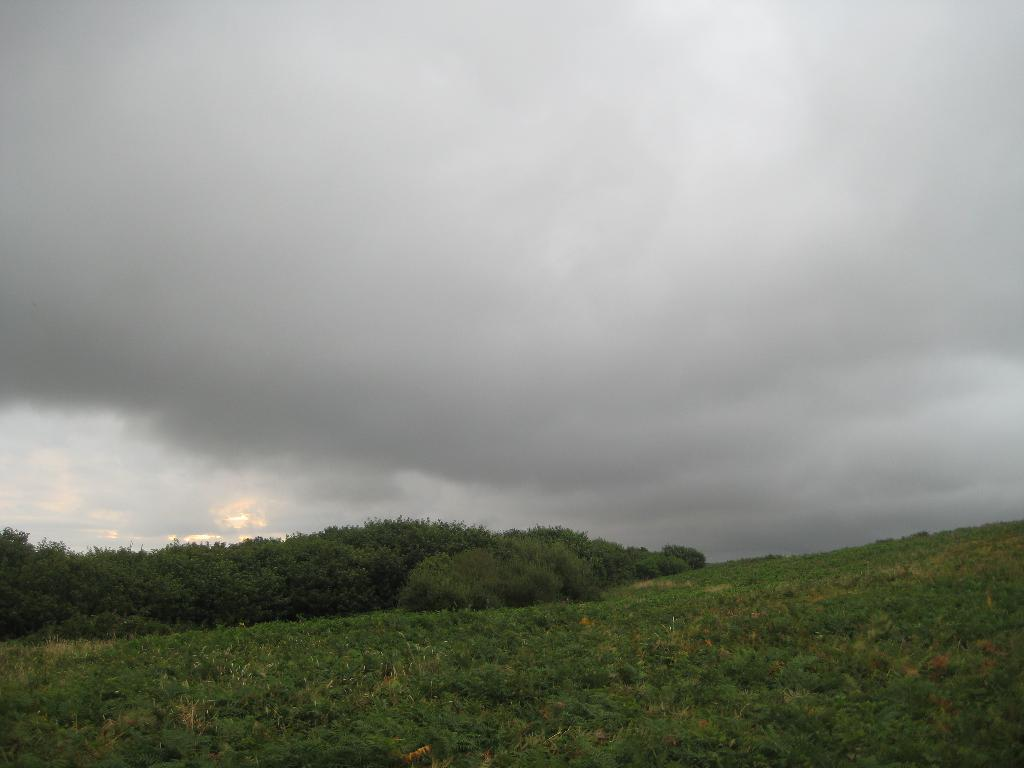What type of vegetation can be seen in the image? There are trees and plants in the image. What can be seen in the sky in the image? There are clouds in the sky. What type of railway is visible in the image? There is no railway present in the image. Can you tell me how many baseballs are in the image? There are no baseballs present in the image. 